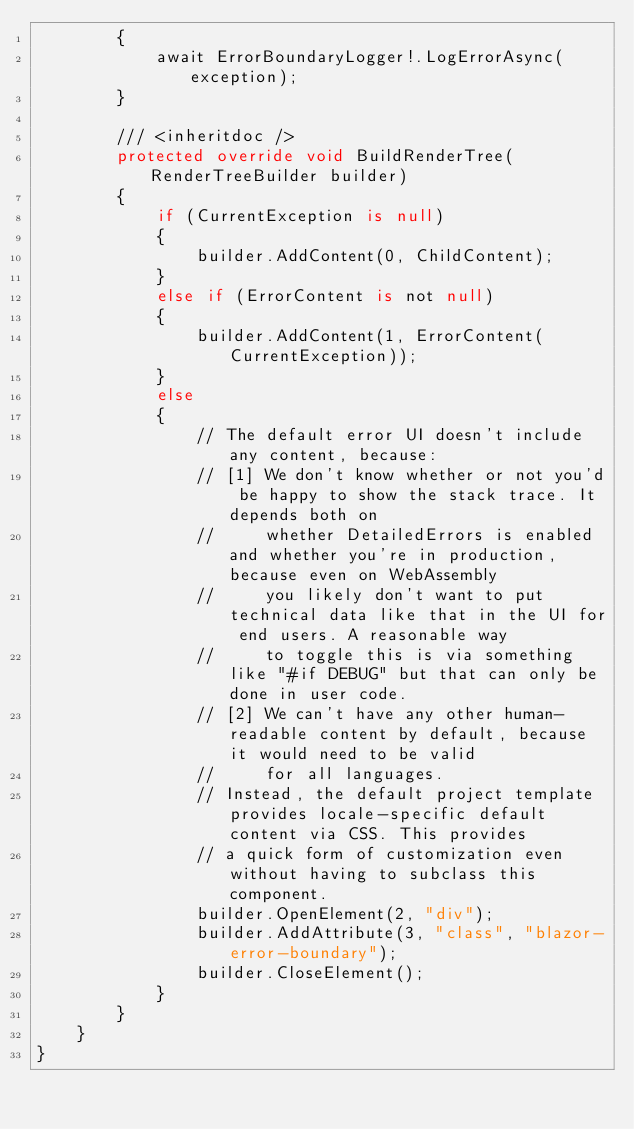<code> <loc_0><loc_0><loc_500><loc_500><_C#_>        {
            await ErrorBoundaryLogger!.LogErrorAsync(exception);
        }

        /// <inheritdoc />
        protected override void BuildRenderTree(RenderTreeBuilder builder)
        {
            if (CurrentException is null)
            {
                builder.AddContent(0, ChildContent);
            }
            else if (ErrorContent is not null)
            {
                builder.AddContent(1, ErrorContent(CurrentException));
            }
            else
            {
                // The default error UI doesn't include any content, because:
                // [1] We don't know whether or not you'd be happy to show the stack trace. It depends both on
                //     whether DetailedErrors is enabled and whether you're in production, because even on WebAssembly
                //     you likely don't want to put technical data like that in the UI for end users. A reasonable way
                //     to toggle this is via something like "#if DEBUG" but that can only be done in user code.
                // [2] We can't have any other human-readable content by default, because it would need to be valid
                //     for all languages.
                // Instead, the default project template provides locale-specific default content via CSS. This provides
                // a quick form of customization even without having to subclass this component.
                builder.OpenElement(2, "div");
                builder.AddAttribute(3, "class", "blazor-error-boundary");
                builder.CloseElement();
            }
        }
    }
}
</code> 